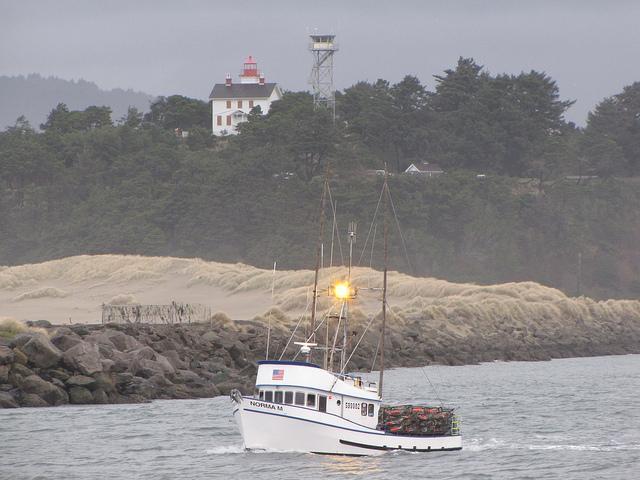How many girls in the picture?
Give a very brief answer. 0. 